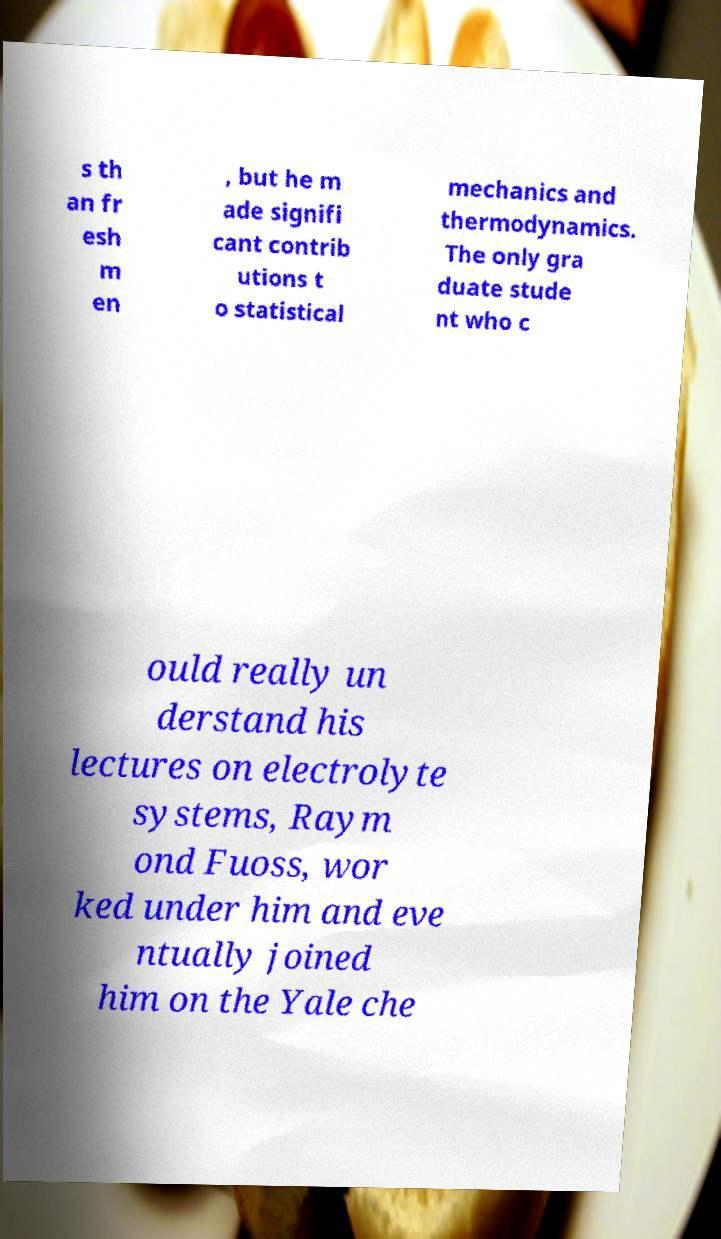Can you read and provide the text displayed in the image?This photo seems to have some interesting text. Can you extract and type it out for me? s th an fr esh m en , but he m ade signifi cant contrib utions t o statistical mechanics and thermodynamics. The only gra duate stude nt who c ould really un derstand his lectures on electrolyte systems, Raym ond Fuoss, wor ked under him and eve ntually joined him on the Yale che 